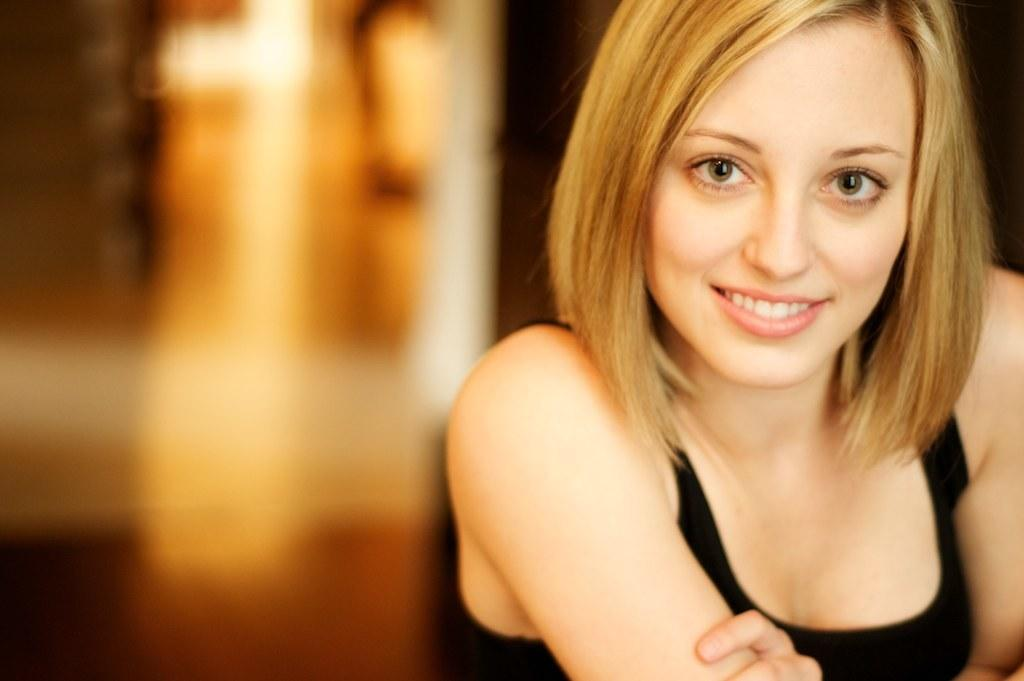What can be observed about the background of the picture? The background portion of the picture is blurred. Where is the woman located in the picture? The woman is on the right side of the picture. What is the woman wearing in the picture? The woman is wearing a black dress. How would you describe the woman's hairstyle in the picture? The woman's hair length is short. What is the woman's facial expression in the picture? The woman is smiling. What is the name of the woman's grandfather in the picture? There is no information about the woman's grandfather in the picture, as the focus is on the woman's appearance and expression. 